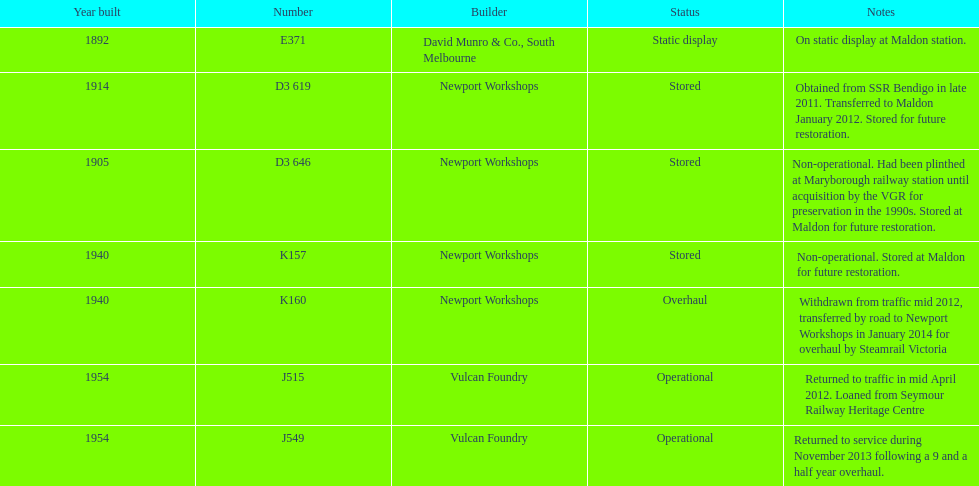Which are the only trains still in service? J515, J549. Could you parse the entire table? {'header': ['Year built', 'Number', 'Builder', 'Status', 'Notes'], 'rows': [['1892', 'E371', 'David Munro & Co., South Melbourne', 'Static display', 'On static display at Maldon station.'], ['1914', 'D3 619', 'Newport Workshops', 'Stored', 'Obtained from SSR Bendigo in late 2011. Transferred to Maldon January 2012. Stored for future restoration.'], ['1905', 'D3 646', 'Newport Workshops', 'Stored', 'Non-operational. Had been plinthed at Maryborough railway station until acquisition by the VGR for preservation in the 1990s. Stored at Maldon for future restoration.'], ['1940', 'K157', 'Newport Workshops', 'Stored', 'Non-operational. Stored at Maldon for future restoration.'], ['1940', 'K160', 'Newport Workshops', 'Overhaul', 'Withdrawn from traffic mid 2012, transferred by road to Newport Workshops in January 2014 for overhaul by Steamrail Victoria'], ['1954', 'J515', 'Vulcan Foundry', 'Operational', 'Returned to traffic in mid April 2012. Loaned from Seymour Railway Heritage Centre'], ['1954', 'J549', 'Vulcan Foundry', 'Operational', 'Returned to service during November 2013 following a 9 and a half year overhaul.']]} 